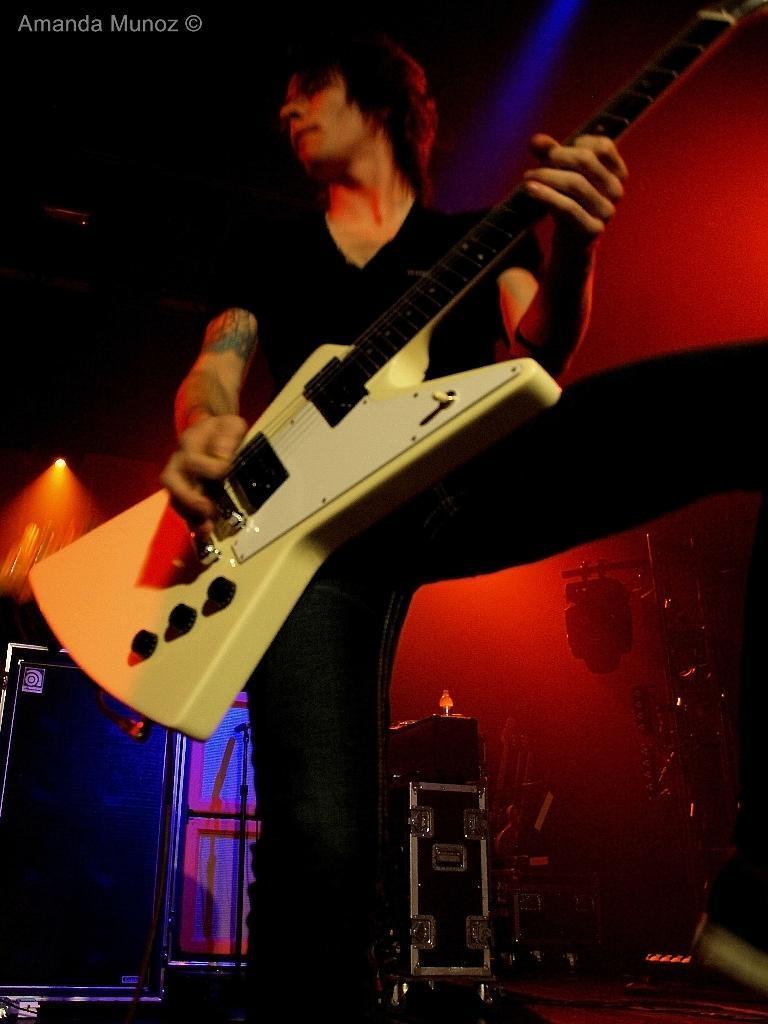Describe this image in one or two sentences. In this picture we can see men standing and holding guitar with his hand and playing it and in the background we can see wall, box, door, rods, speakers, light and it is dark. 